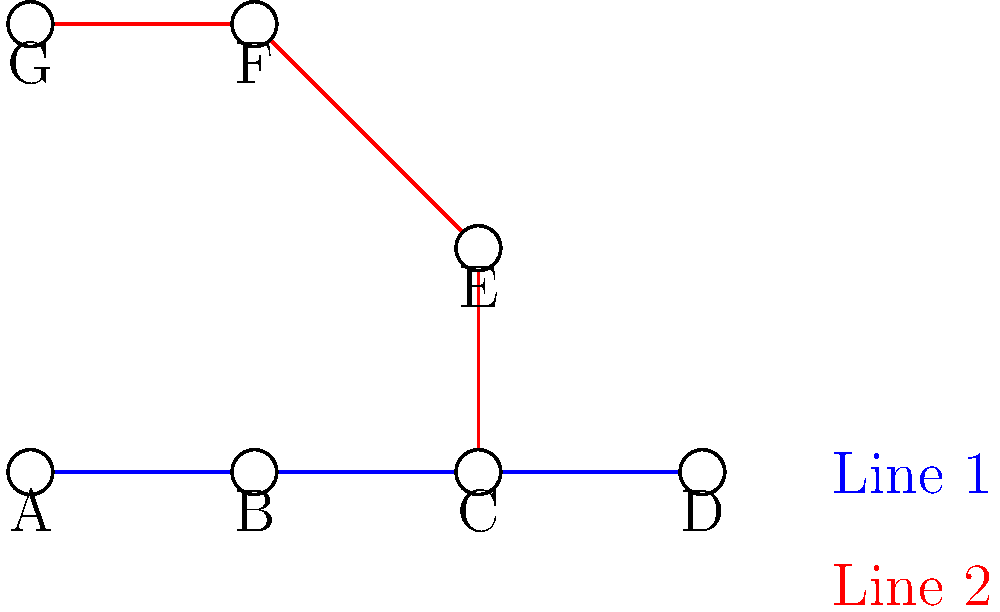Based on the simplified Tianjin metro network diagram, if each segment between adjacent stations takes approximately 3 minutes to travel, and transferring between lines at an interchange station takes about 4 minutes, estimate the total travel time from station A to station F. Let's break down the journey from station A to station F step by step:

1. Count the number of segments:
   - From A to C: 2 segments on Line 1 (blue)
   - From C to F: 2 segments on Line 2 (red)
   Total segments: 2 + 2 = 4 segments

2. Calculate time for traveling segments:
   - Time per segment = 3 minutes
   - Total segment time = 4 segments × 3 minutes = 12 minutes

3. Account for the transfer at station C:
   - Transfer time = 4 minutes

4. Sum up the total travel time:
   - Total time = Segment time + Transfer time
   - Total time = 12 minutes + 4 minutes = 16 minutes

Therefore, the estimated total travel time from station A to station F is 16 minutes.
Answer: 16 minutes 